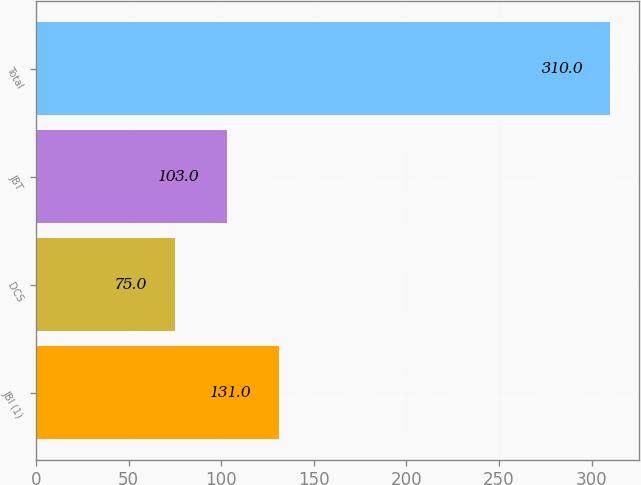<chart> <loc_0><loc_0><loc_500><loc_500><bar_chart><fcel>JBI (1)<fcel>DCS<fcel>JBT<fcel>Total<nl><fcel>131<fcel>75<fcel>103<fcel>310<nl></chart> 